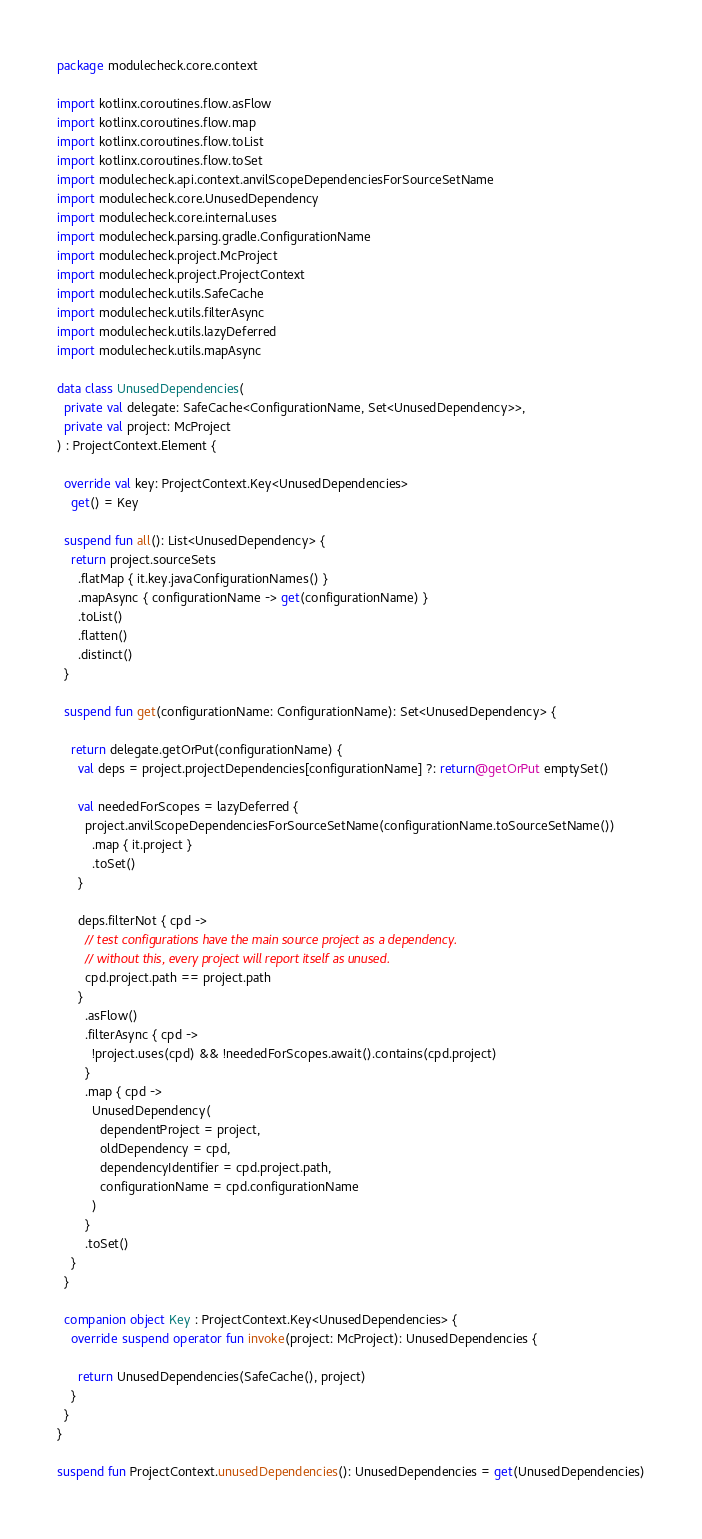<code> <loc_0><loc_0><loc_500><loc_500><_Kotlin_>
package modulecheck.core.context

import kotlinx.coroutines.flow.asFlow
import kotlinx.coroutines.flow.map
import kotlinx.coroutines.flow.toList
import kotlinx.coroutines.flow.toSet
import modulecheck.api.context.anvilScopeDependenciesForSourceSetName
import modulecheck.core.UnusedDependency
import modulecheck.core.internal.uses
import modulecheck.parsing.gradle.ConfigurationName
import modulecheck.project.McProject
import modulecheck.project.ProjectContext
import modulecheck.utils.SafeCache
import modulecheck.utils.filterAsync
import modulecheck.utils.lazyDeferred
import modulecheck.utils.mapAsync

data class UnusedDependencies(
  private val delegate: SafeCache<ConfigurationName, Set<UnusedDependency>>,
  private val project: McProject
) : ProjectContext.Element {

  override val key: ProjectContext.Key<UnusedDependencies>
    get() = Key

  suspend fun all(): List<UnusedDependency> {
    return project.sourceSets
      .flatMap { it.key.javaConfigurationNames() }
      .mapAsync { configurationName -> get(configurationName) }
      .toList()
      .flatten()
      .distinct()
  }

  suspend fun get(configurationName: ConfigurationName): Set<UnusedDependency> {

    return delegate.getOrPut(configurationName) {
      val deps = project.projectDependencies[configurationName] ?: return@getOrPut emptySet()

      val neededForScopes = lazyDeferred {
        project.anvilScopeDependenciesForSourceSetName(configurationName.toSourceSetName())
          .map { it.project }
          .toSet()
      }

      deps.filterNot { cpd ->
        // test configurations have the main source project as a dependency.
        // without this, every project will report itself as unused.
        cpd.project.path == project.path
      }
        .asFlow()
        .filterAsync { cpd ->
          !project.uses(cpd) && !neededForScopes.await().contains(cpd.project)
        }
        .map { cpd ->
          UnusedDependency(
            dependentProject = project,
            oldDependency = cpd,
            dependencyIdentifier = cpd.project.path,
            configurationName = cpd.configurationName
          )
        }
        .toSet()
    }
  }

  companion object Key : ProjectContext.Key<UnusedDependencies> {
    override suspend operator fun invoke(project: McProject): UnusedDependencies {

      return UnusedDependencies(SafeCache(), project)
    }
  }
}

suspend fun ProjectContext.unusedDependencies(): UnusedDependencies = get(UnusedDependencies)
</code> 